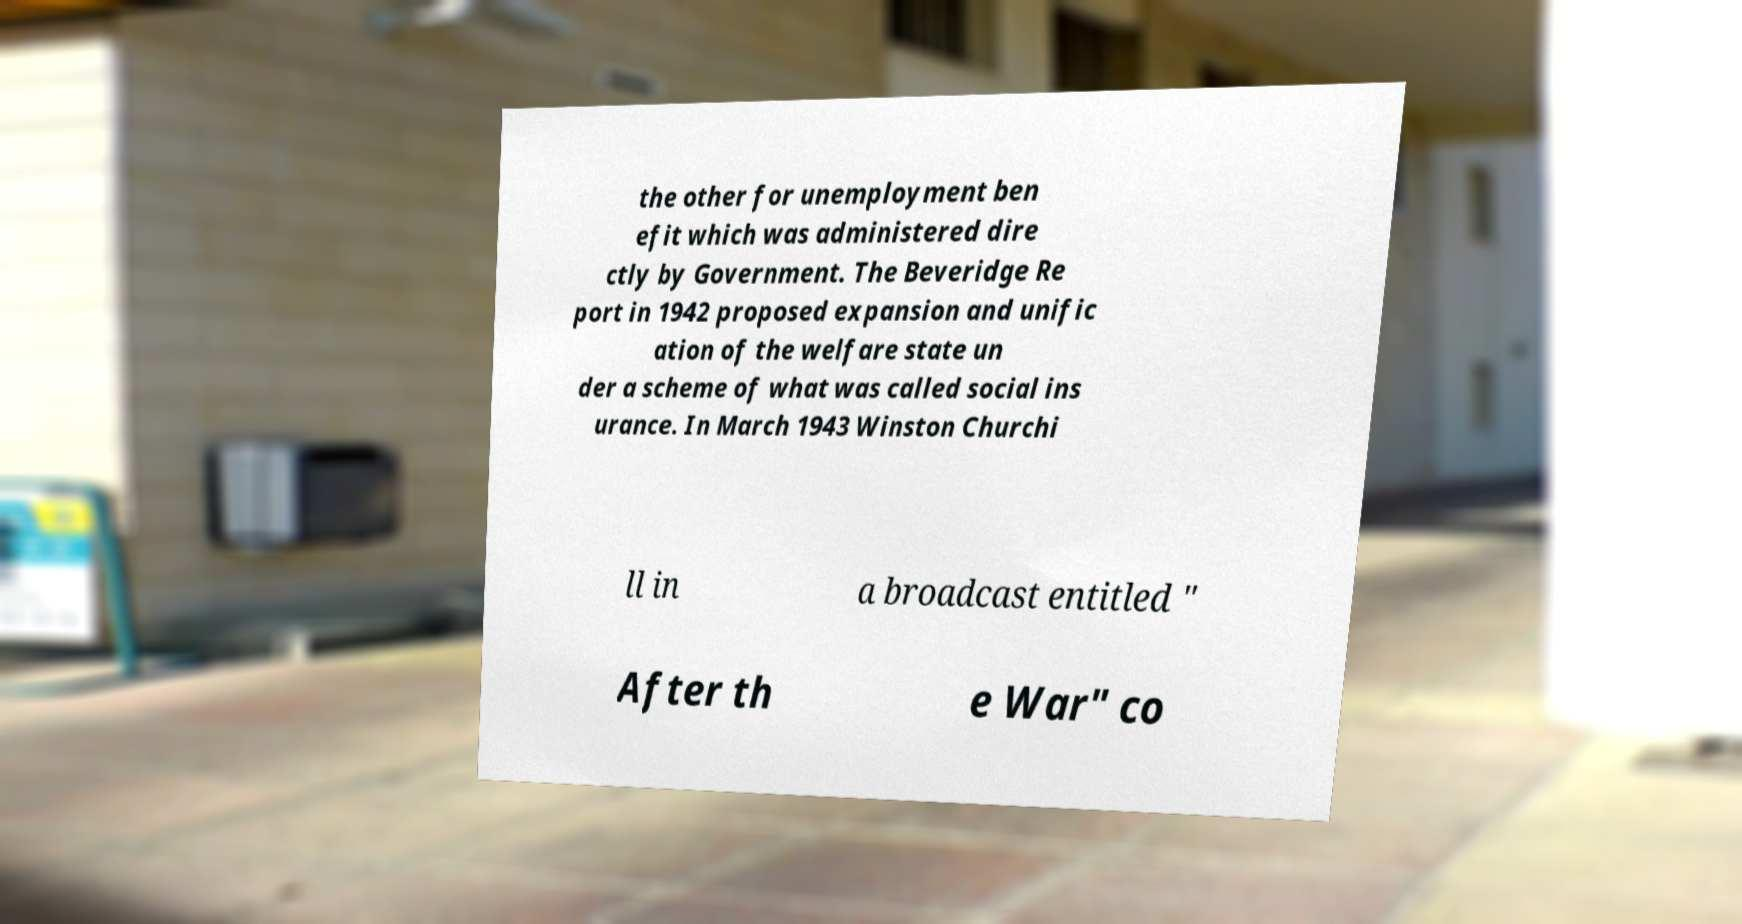Can you read and provide the text displayed in the image?This photo seems to have some interesting text. Can you extract and type it out for me? the other for unemployment ben efit which was administered dire ctly by Government. The Beveridge Re port in 1942 proposed expansion and unific ation of the welfare state un der a scheme of what was called social ins urance. In March 1943 Winston Churchi ll in a broadcast entitled " After th e War" co 